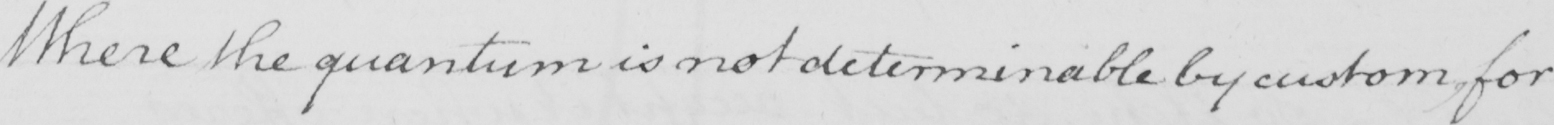Please provide the text content of this handwritten line. Where the quantum is not determinable by custom , for 